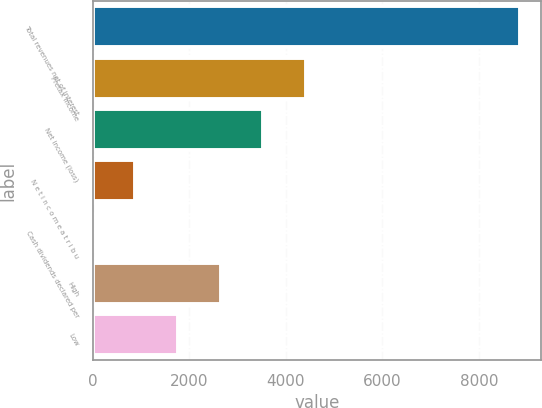Convert chart to OTSL. <chart><loc_0><loc_0><loc_500><loc_500><bar_chart><fcel>Total revenues net of interest<fcel>Pretax income<fcel>Net income (loss)<fcel>N e t i n c o m e a t r i b u<fcel>Cash dividends declared per<fcel>High<fcel>Low<nl><fcel>8839<fcel>4419.68<fcel>3535.81<fcel>884.22<fcel>0.35<fcel>2651.95<fcel>1768.09<nl></chart> 